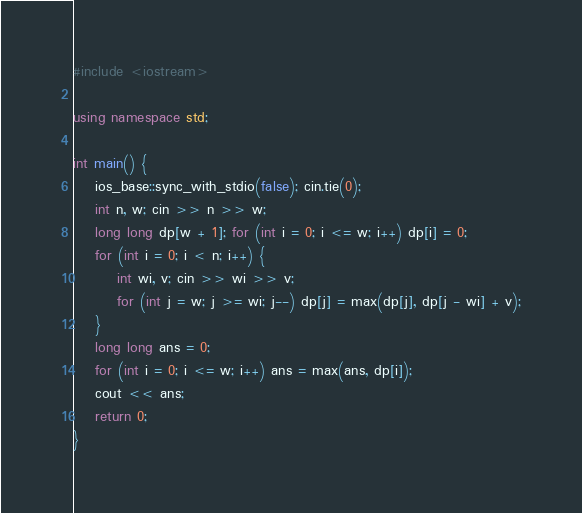Convert code to text. <code><loc_0><loc_0><loc_500><loc_500><_C++_>#include <iostream>

using namespace std;

int main() {
    ios_base::sync_with_stdio(false); cin.tie(0);
    int n, w; cin >> n >> w;
    long long dp[w + 1]; for (int i = 0; i <= w; i++) dp[i] = 0;
    for (int i = 0; i < n; i++) {
        int wi, v; cin >> wi >> v;
        for (int j = w; j >= wi; j--) dp[j] = max(dp[j], dp[j - wi] + v);
    }
    long long ans = 0;
    for (int i = 0; i <= w; i++) ans = max(ans, dp[i]);
    cout << ans;
    return 0;
}
</code> 